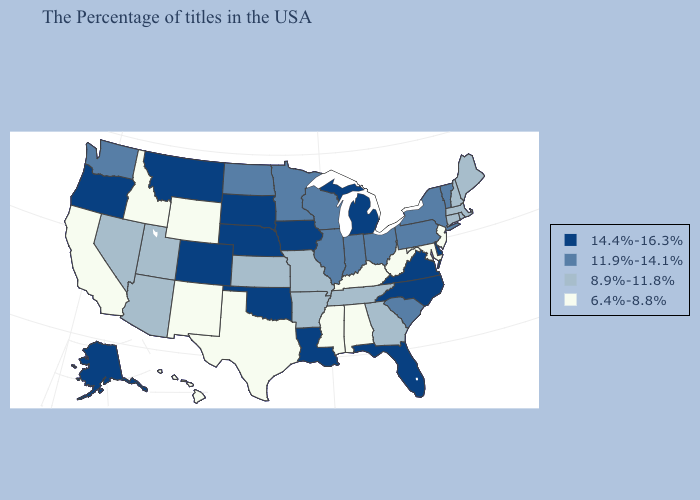Among the states that border Minnesota , does Iowa have the highest value?
Keep it brief. Yes. What is the highest value in the USA?
Concise answer only. 14.4%-16.3%. Does Mississippi have the lowest value in the USA?
Write a very short answer. Yes. Does Alabama have a higher value than Louisiana?
Be succinct. No. What is the lowest value in states that border North Dakota?
Quick response, please. 11.9%-14.1%. Which states hav the highest value in the West?
Be succinct. Colorado, Montana, Oregon, Alaska. Does Rhode Island have the lowest value in the Northeast?
Concise answer only. No. Among the states that border Colorado , does Kansas have the lowest value?
Be succinct. No. Which states have the lowest value in the USA?
Quick response, please. New Jersey, Maryland, West Virginia, Kentucky, Alabama, Mississippi, Texas, Wyoming, New Mexico, Idaho, California, Hawaii. Name the states that have a value in the range 11.9%-14.1%?
Keep it brief. Vermont, New York, Pennsylvania, South Carolina, Ohio, Indiana, Wisconsin, Illinois, Minnesota, North Dakota, Washington. Among the states that border Vermont , which have the highest value?
Write a very short answer. New York. Name the states that have a value in the range 14.4%-16.3%?
Be succinct. Delaware, Virginia, North Carolina, Florida, Michigan, Louisiana, Iowa, Nebraska, Oklahoma, South Dakota, Colorado, Montana, Oregon, Alaska. Does Hawaii have the lowest value in the USA?
Short answer required. Yes. Name the states that have a value in the range 6.4%-8.8%?
Answer briefly. New Jersey, Maryland, West Virginia, Kentucky, Alabama, Mississippi, Texas, Wyoming, New Mexico, Idaho, California, Hawaii. 